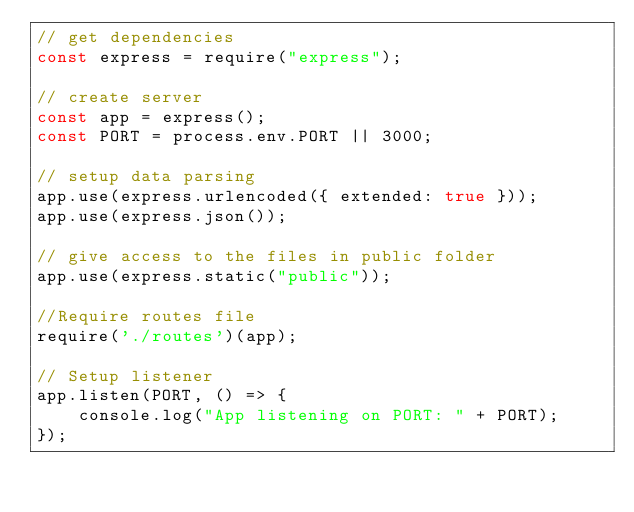Convert code to text. <code><loc_0><loc_0><loc_500><loc_500><_JavaScript_>// get dependencies
const express = require("express");

// create server 
const app = express();
const PORT = process.env.PORT || 3000;

// setup data parsing
app.use(express.urlencoded({ extended: true }));
app.use(express.json());

// give access to the files in public folder
app.use(express.static("public"));

//Require routes file
require('./routes')(app);

// Setup listener
app.listen(PORT, () => {
    console.log("App listening on PORT: " + PORT);
});  </code> 